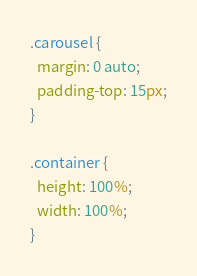<code> <loc_0><loc_0><loc_500><loc_500><_CSS_>.carousel {
  margin: 0 auto;
  padding-top: 15px;
}

.container {
  height: 100%;
  width: 100%;
}

</code> 